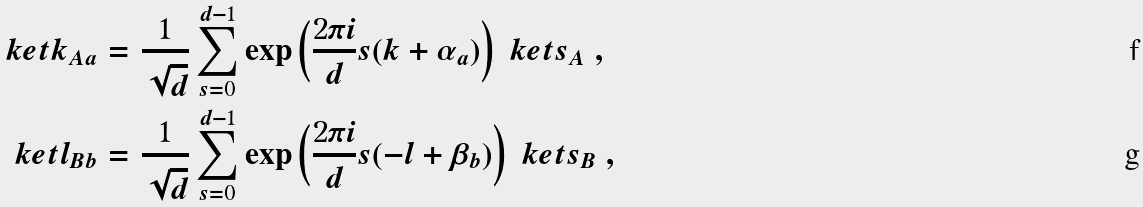<formula> <loc_0><loc_0><loc_500><loc_500>\ k e t { k } _ { A a } & = \frac { 1 } { \sqrt { d } } \sum _ { s = 0 } ^ { d - 1 } \exp \left ( \frac { 2 \pi i } { d } s ( k + \alpha _ { a } ) \right ) \ k e t { s } _ { A } \ , \\ \ k e t { l } _ { B b } & = \frac { 1 } { \sqrt { d } } \sum _ { s = 0 } ^ { d - 1 } \exp \left ( \frac { 2 \pi i } { d } s ( - l + \beta _ { b } ) \right ) \ k e t { s } _ { B } \ ,</formula> 